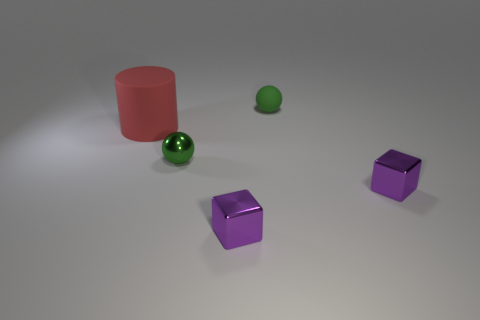Subtract 1 cylinders. How many cylinders are left? 0 Subtract all spheres. How many objects are left? 3 Subtract all brown spheres. Subtract all blue cylinders. How many spheres are left? 2 Subtract all purple cylinders. How many red spheres are left? 0 Subtract all purple rubber blocks. Subtract all small green balls. How many objects are left? 3 Add 5 tiny matte objects. How many tiny matte objects are left? 6 Add 5 blue cylinders. How many blue cylinders exist? 5 Add 1 tiny gray matte spheres. How many objects exist? 6 Subtract 1 purple cubes. How many objects are left? 4 